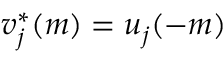<formula> <loc_0><loc_0><loc_500><loc_500>v _ { j } ^ { * } ( m ) = u _ { j } ( - m )</formula> 